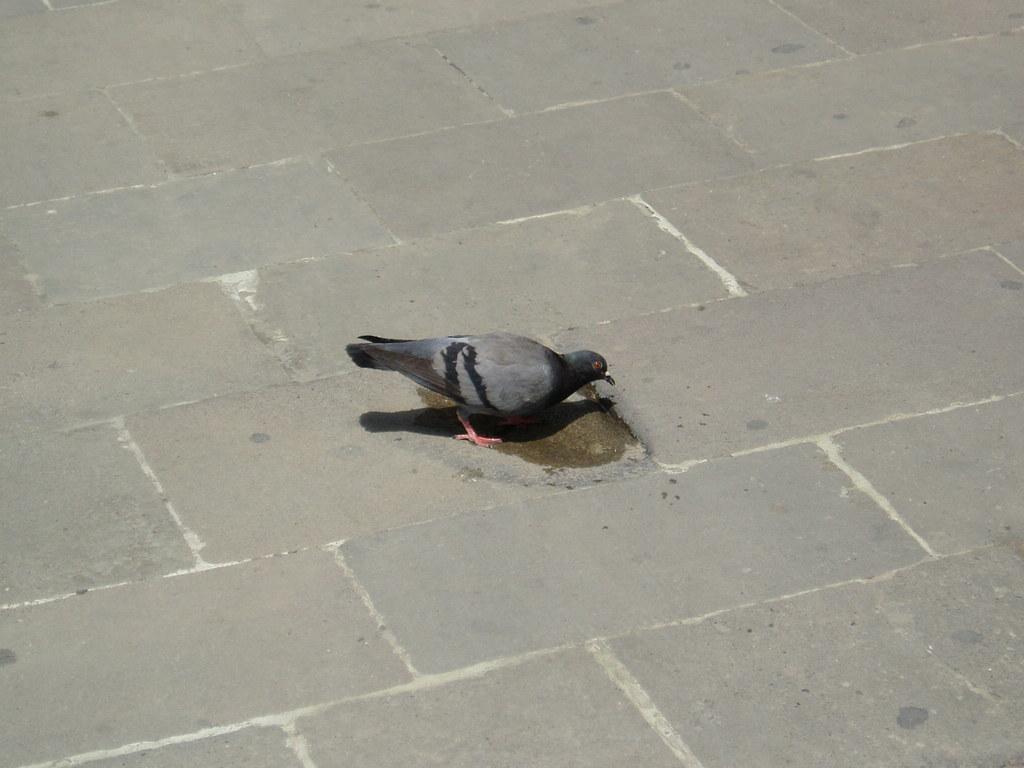Can you describe this image briefly? In this picture there is a pigeon in the center of the image. 